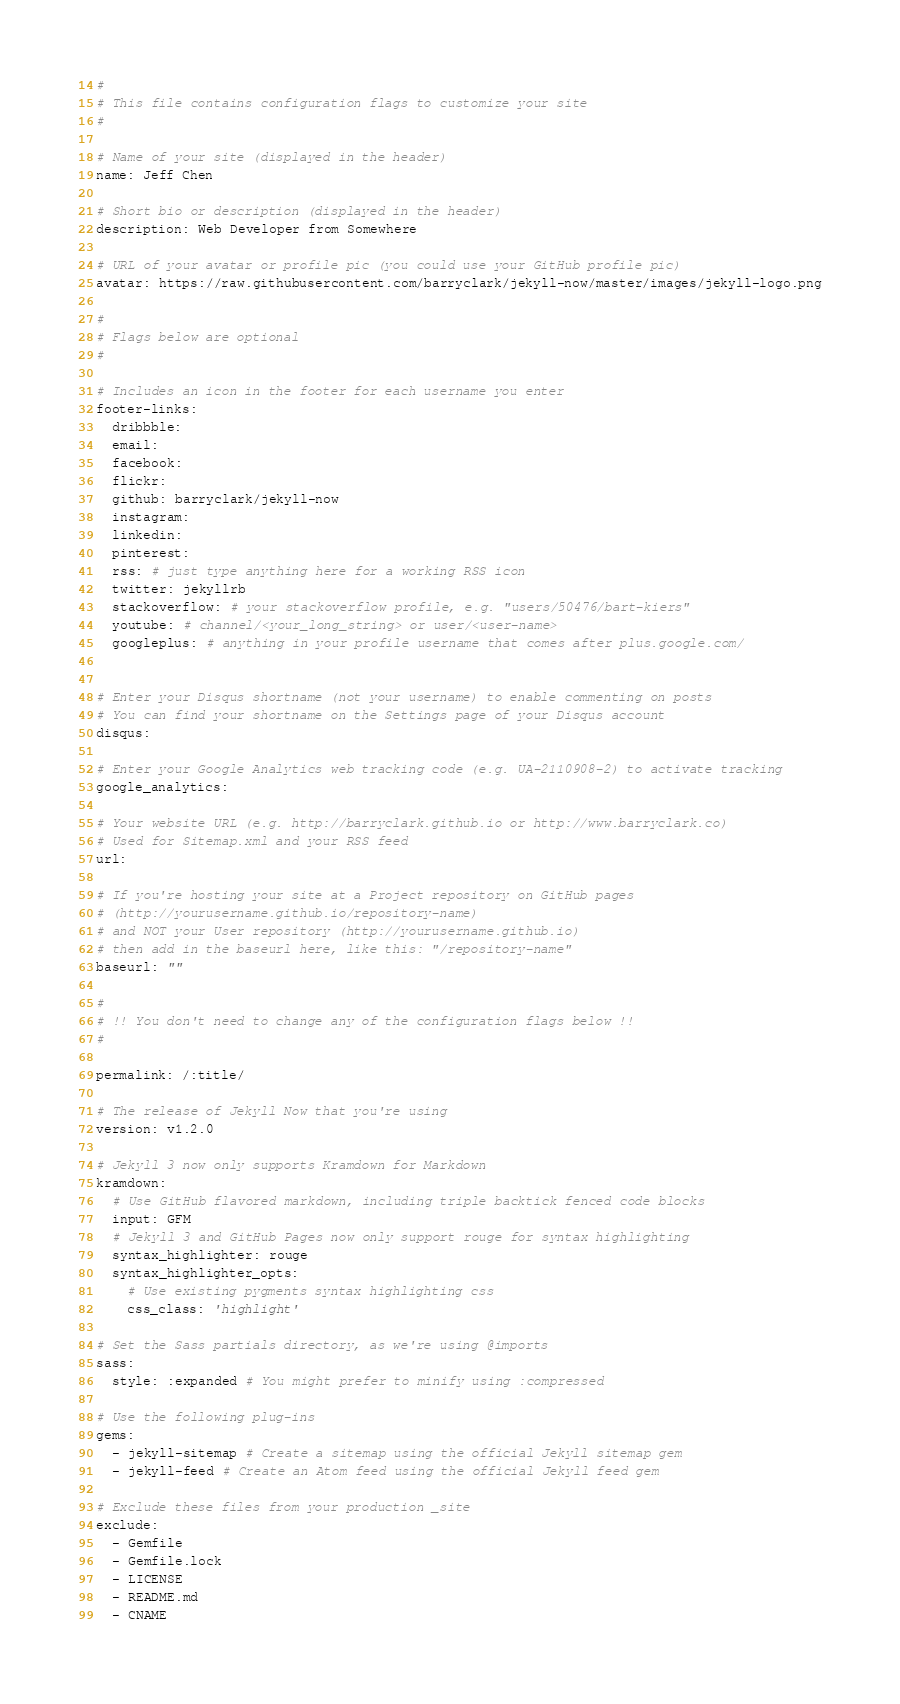<code> <loc_0><loc_0><loc_500><loc_500><_YAML_>#
# This file contains configuration flags to customize your site
#

# Name of your site (displayed in the header)
name: Jeff Chen

# Short bio or description (displayed in the header)
description: Web Developer from Somewhere

# URL of your avatar or profile pic (you could use your GitHub profile pic)
avatar: https://raw.githubusercontent.com/barryclark/jekyll-now/master/images/jekyll-logo.png

#
# Flags below are optional
#

# Includes an icon in the footer for each username you enter
footer-links:
  dribbble:
  email:
  facebook:
  flickr:
  github: barryclark/jekyll-now
  instagram:
  linkedin:
  pinterest:
  rss: # just type anything here for a working RSS icon
  twitter: jekyllrb
  stackoverflow: # your stackoverflow profile, e.g. "users/50476/bart-kiers"
  youtube: # channel/<your_long_string> or user/<user-name>
  googleplus: # anything in your profile username that comes after plus.google.com/


# Enter your Disqus shortname (not your username) to enable commenting on posts
# You can find your shortname on the Settings page of your Disqus account
disqus:

# Enter your Google Analytics web tracking code (e.g. UA-2110908-2) to activate tracking
google_analytics:

# Your website URL (e.g. http://barryclark.github.io or http://www.barryclark.co)
# Used for Sitemap.xml and your RSS feed
url:

# If you're hosting your site at a Project repository on GitHub pages
# (http://yourusername.github.io/repository-name)
# and NOT your User repository (http://yourusername.github.io)
# then add in the baseurl here, like this: "/repository-name"
baseurl: ""

#
# !! You don't need to change any of the configuration flags below !!
#

permalink: /:title/

# The release of Jekyll Now that you're using
version: v1.2.0

# Jekyll 3 now only supports Kramdown for Markdown
kramdown:
  # Use GitHub flavored markdown, including triple backtick fenced code blocks
  input: GFM
  # Jekyll 3 and GitHub Pages now only support rouge for syntax highlighting
  syntax_highlighter: rouge
  syntax_highlighter_opts:
    # Use existing pygments syntax highlighting css
    css_class: 'highlight'

# Set the Sass partials directory, as we're using @imports
sass:
  style: :expanded # You might prefer to minify using :compressed

# Use the following plug-ins
gems:
  - jekyll-sitemap # Create a sitemap using the official Jekyll sitemap gem
  - jekyll-feed # Create an Atom feed using the official Jekyll feed gem

# Exclude these files from your production _site
exclude:
  - Gemfile
  - Gemfile.lock
  - LICENSE
  - README.md
  - CNAME
</code> 